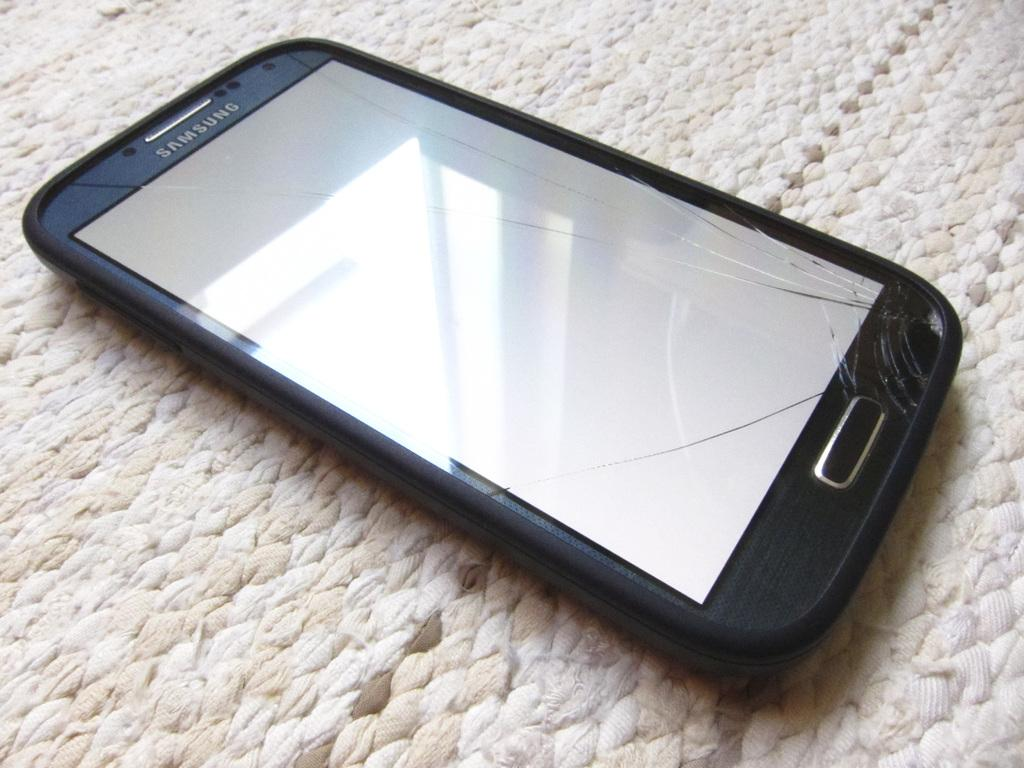<image>
Render a clear and concise summary of the photo. A cracked Samsung cell phone sits on a white blanket. 